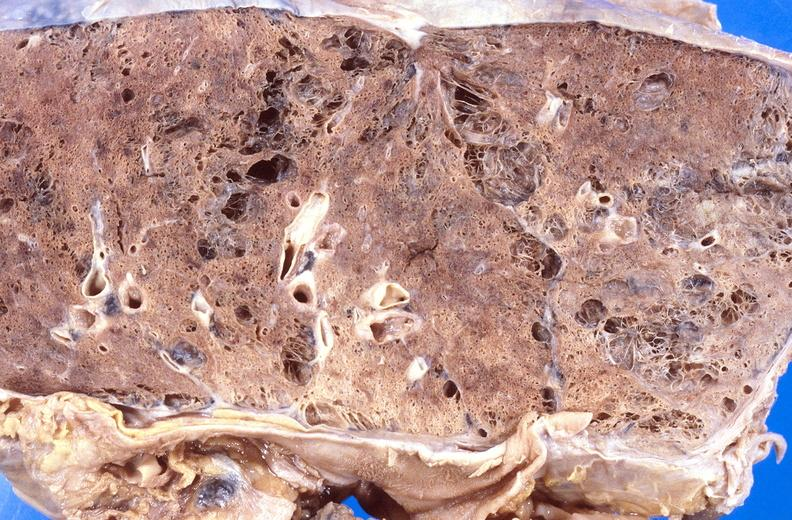s traumatic rupture present?
Answer the question using a single word or phrase. No 